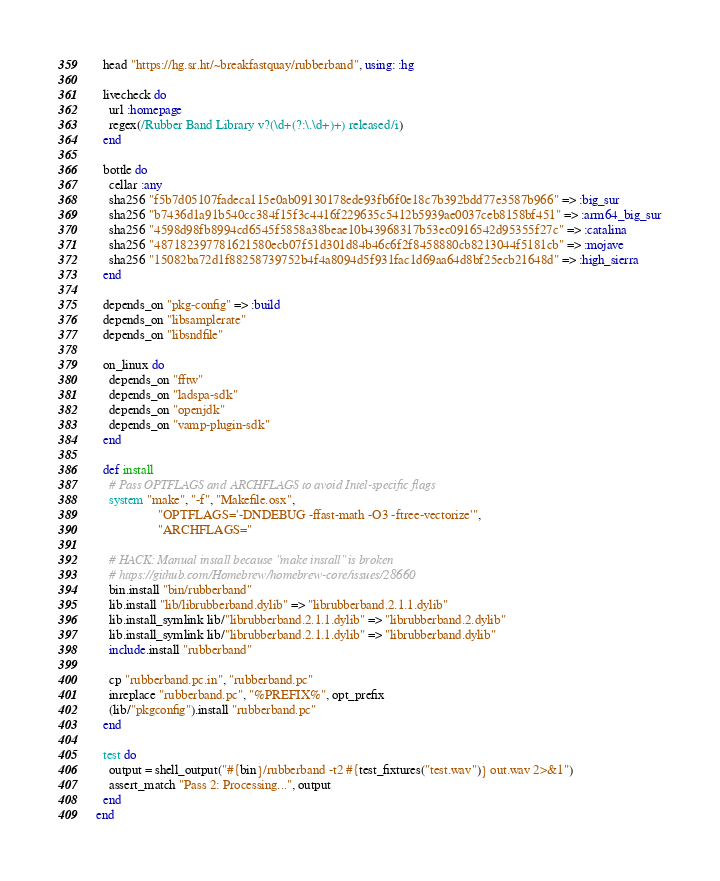<code> <loc_0><loc_0><loc_500><loc_500><_Ruby_>  head "https://hg.sr.ht/~breakfastquay/rubberband", using: :hg

  livecheck do
    url :homepage
    regex(/Rubber Band Library v?(\d+(?:\.\d+)+) released/i)
  end

  bottle do
    cellar :any
    sha256 "f5b7d05107fadeca115e0ab09130178ede93fb6f0e18c7b392bdd77e3587b966" => :big_sur
    sha256 "b7436d1a91b540cc384f15f3c4416f229635c5412b5939ae0037ceb8158bf451" => :arm64_big_sur
    sha256 "4598d98fb8994cd6545f5858a38beae10b43968317b53ec0916542d95355f27c" => :catalina
    sha256 "487182397781621580ecb07f51d301d84b46c6f2f8458880cb8213044f5181cb" => :mojave
    sha256 "15082ba72d1f88258739752b4f4a8094d5f931fac1d69aa64d8bf25ecb21648d" => :high_sierra
  end

  depends_on "pkg-config" => :build
  depends_on "libsamplerate"
  depends_on "libsndfile"

  on_linux do
    depends_on "fftw"
    depends_on "ladspa-sdk"
    depends_on "openjdk"
    depends_on "vamp-plugin-sdk"
  end

  def install
    # Pass OPTFLAGS and ARCHFLAGS to avoid Intel-specific flags
    system "make", "-f", "Makefile.osx",
                   "OPTFLAGS='-DNDEBUG -ffast-math -O3 -ftree-vectorize'",
                   "ARCHFLAGS="

    # HACK: Manual install because "make install" is broken
    # https://github.com/Homebrew/homebrew-core/issues/28660
    bin.install "bin/rubberband"
    lib.install "lib/librubberband.dylib" => "librubberband.2.1.1.dylib"
    lib.install_symlink lib/"librubberband.2.1.1.dylib" => "librubberband.2.dylib"
    lib.install_symlink lib/"librubberband.2.1.1.dylib" => "librubberband.dylib"
    include.install "rubberband"

    cp "rubberband.pc.in", "rubberband.pc"
    inreplace "rubberband.pc", "%PREFIX%", opt_prefix
    (lib/"pkgconfig").install "rubberband.pc"
  end

  test do
    output = shell_output("#{bin}/rubberband -t2 #{test_fixtures("test.wav")} out.wav 2>&1")
    assert_match "Pass 2: Processing...", output
  end
end
</code> 